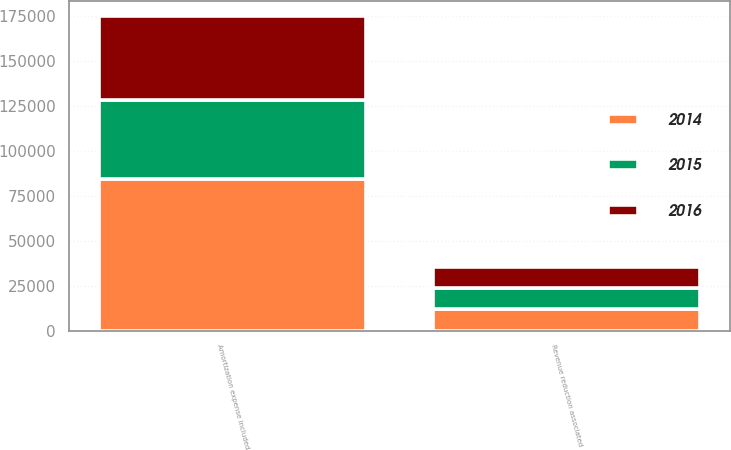Convert chart. <chart><loc_0><loc_0><loc_500><loc_500><stacked_bar_chart><ecel><fcel>Amortization expense included<fcel>Revenue reduction associated<nl><fcel>2016<fcel>46733<fcel>11715<nl><fcel>2015<fcel>43614<fcel>11670<nl><fcel>2014<fcel>84349<fcel>12217<nl></chart> 